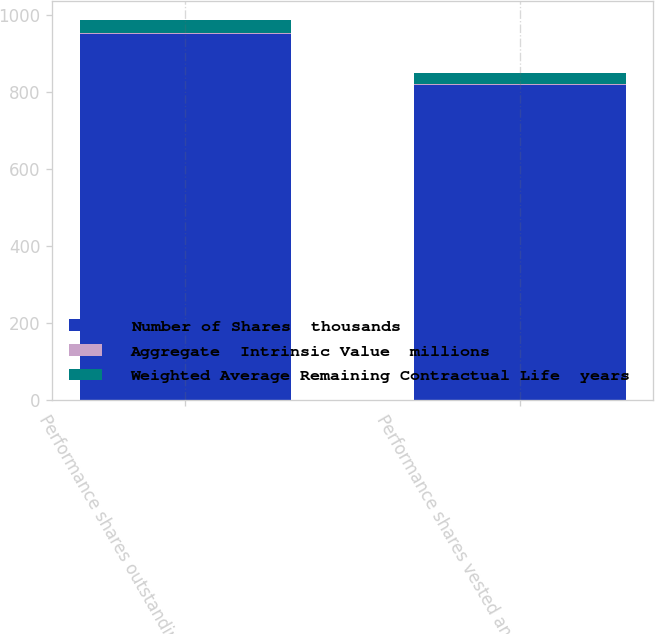Convert chart to OTSL. <chart><loc_0><loc_0><loc_500><loc_500><stacked_bar_chart><ecel><fcel>Performance shares outstanding<fcel>Performance shares vested and<nl><fcel>Number of Shares  thousands<fcel>950<fcel>818<nl><fcel>Aggregate  Intrinsic Value  millions<fcel>1.05<fcel>0.97<nl><fcel>Weighted Average Remaining Contractual Life  years<fcel>33.6<fcel>28.8<nl></chart> 